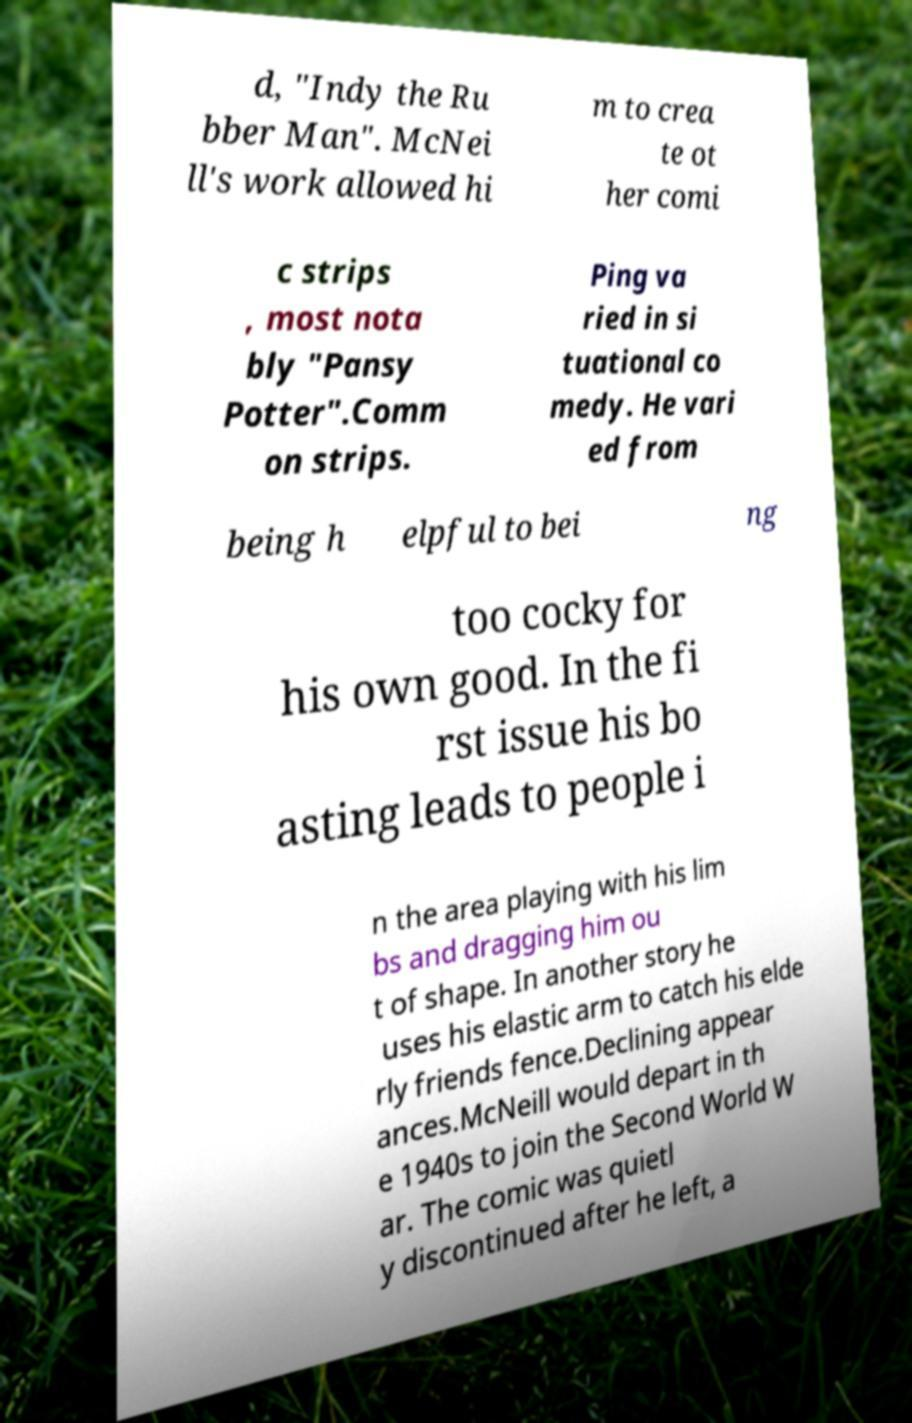Can you accurately transcribe the text from the provided image for me? d, "Indy the Ru bber Man". McNei ll's work allowed hi m to crea te ot her comi c strips , most nota bly "Pansy Potter".Comm on strips. Ping va ried in si tuational co medy. He vari ed from being h elpful to bei ng too cocky for his own good. In the fi rst issue his bo asting leads to people i n the area playing with his lim bs and dragging him ou t of shape. In another story he uses his elastic arm to catch his elde rly friends fence.Declining appear ances.McNeill would depart in th e 1940s to join the Second World W ar. The comic was quietl y discontinued after he left, a 